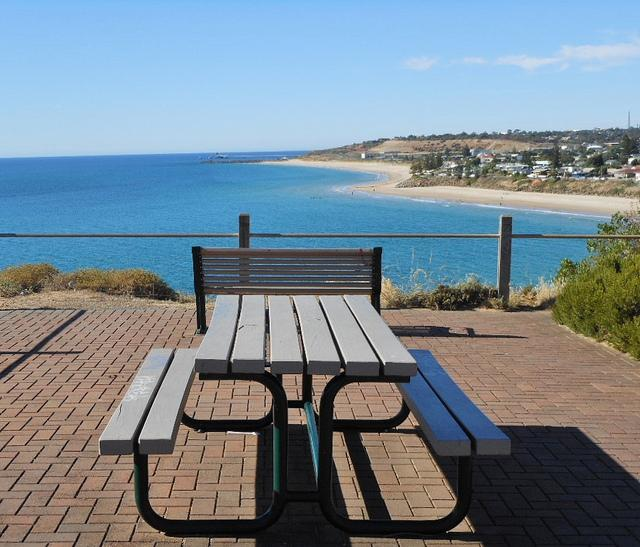What color is the top of the picnic bench painted all up like? grey 